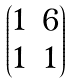Convert formula to latex. <formula><loc_0><loc_0><loc_500><loc_500>\begin{pmatrix} 1 & 6 \\ 1 & 1 \end{pmatrix}</formula> 